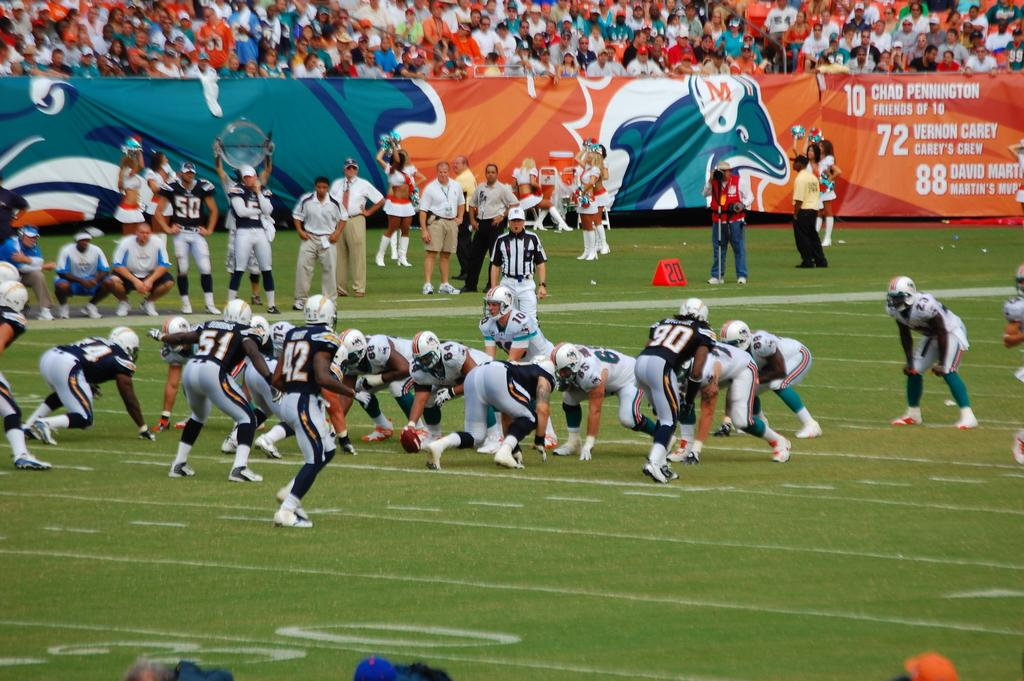What are the people in the image doing? There are people playing on the ground in the image. Is there any signage or decoration visible in the image? Yes, there is a banner visible in the image. Are there any spectators in the image? Yes, there are people sitting and watching the game in the image. What date is marked on the calendar in the image? There is no calendar present in the image. Is there a beggar asking for alms in the image? There is no beggar present in the image. 